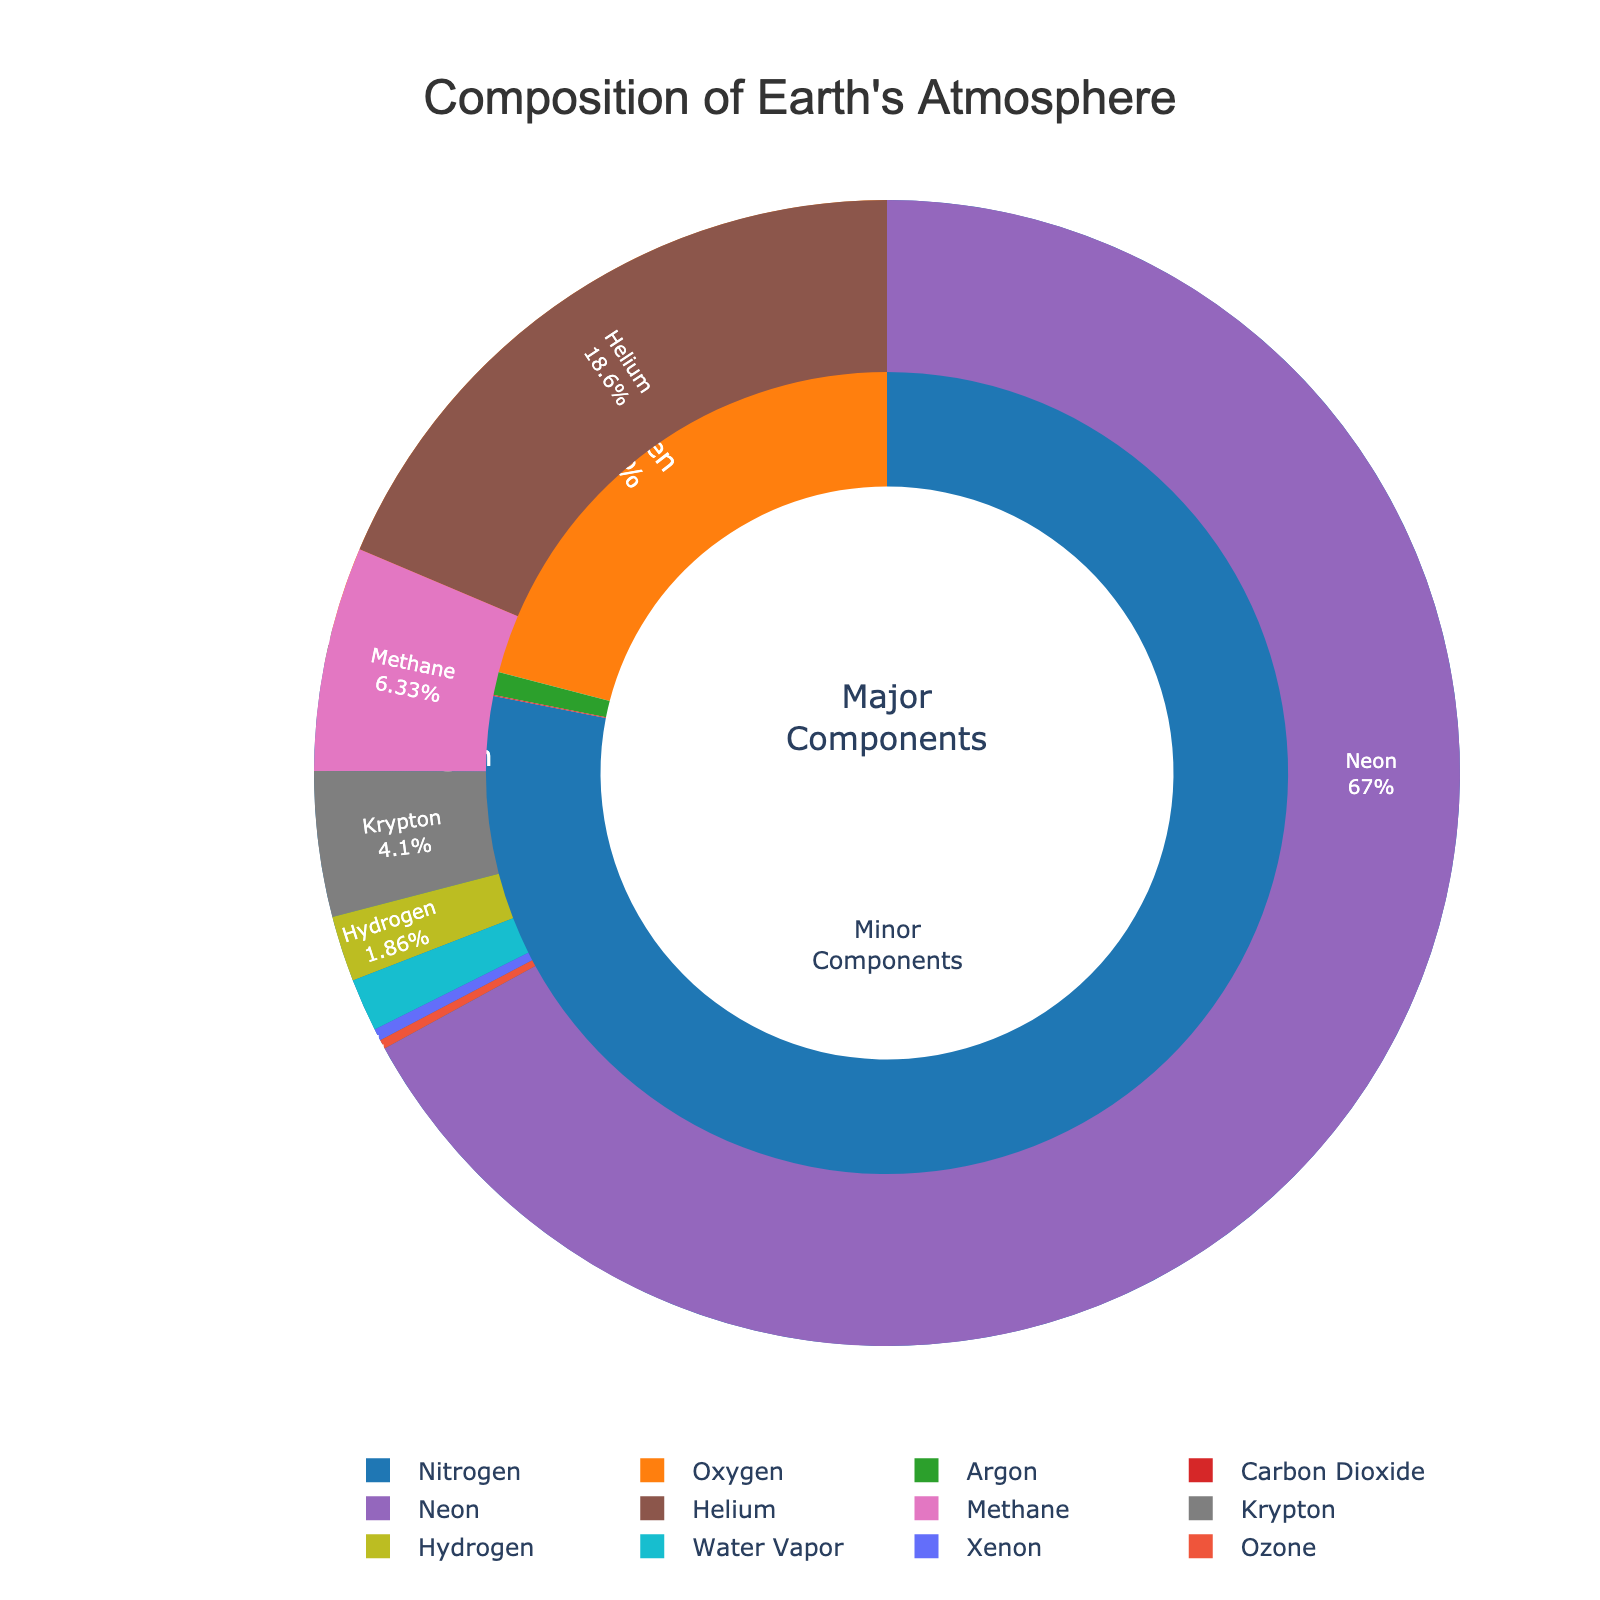What is the percentage of Oxygen in the Earth's atmosphere? The figure shows the major components where Oxygen is labeled directly with its percentage.
Answer: 20.95% Which gas makes up the smallest percentage of the Earth's atmosphere? By examining the minor components in the smaller ring, Ozone has the smallest labeled percentage.
Answer: Ozone How much more abundant is Nitrogen compared to Carbon Dioxide? Nitrogen has a percentage of 78.08%, and Carbon Dioxide has 0.04%. Subtract the percentage of Carbon Dioxide from Nitrogen: 78.08% - 0.04% = 78.04%.
Answer: 78.04% Which gas is the second most abundant in the Earth's atmosphere, and what is its percentage? The top portion of the pie chart where major components are shown lists Oxygen as the second most abundant gas at 20.95%.
Answer: Oxygen, 20.95% Is Argon more or less than 1% of the Earth's atmosphere, and by how much? The major components show Argon's percentage as 0.93%. Compare it to 1%: 1% - 0.93% = 0.07%.
Answer: Less, by 0.07% How do the percentages of Neon and Helium compare? Neon is at 0.0018% and Helium is at 0.0005%. The difference is found by subtracting the smaller from the larger: 0.0018% - 0.0005% = 0.0013%.
Answer: Neon is greater by 0.0013% If you sum up the percentages of the top three gases, what do you get? The top three gases by percentage are Nitrogen (78.08%), Oxygen (20.95%), and Argon (0.93%). Summing them up: 78.08% + 20.95% + 0.93% = 99.96%.
Answer: 99.96% What is the combined percentage of all minor components listed? All components with percentages less than 0.01% are considered minor. Sum their values: Carbon Dioxide (0.04%) + Neon (0.0018%) + Helium (0.0005%) + Methane (0.00017%) + Krypton (0.00011%) + Hydrogen (0.00005%) + Water Vapor (0.00004%) + Xenon (0.000009%) + Ozone (0.000007%) = 0.042636%.
Answer: 0.042636% Which gas is represented by the blue color in the major components section? In the pie chart of major components, Nitrogen is labeled and represented by the blue section.
Answer: Nitrogen What is the total percentage of gases other than Nitrogen and Oxygen? First, the sum of Nitrogen and Oxygen is 78.08% + 20.95% = 99.03%. Then, subtract this from 100% to find the total percentage of all other gases: 100% - 99.03% = 0.97%.
Answer: 0.97% 